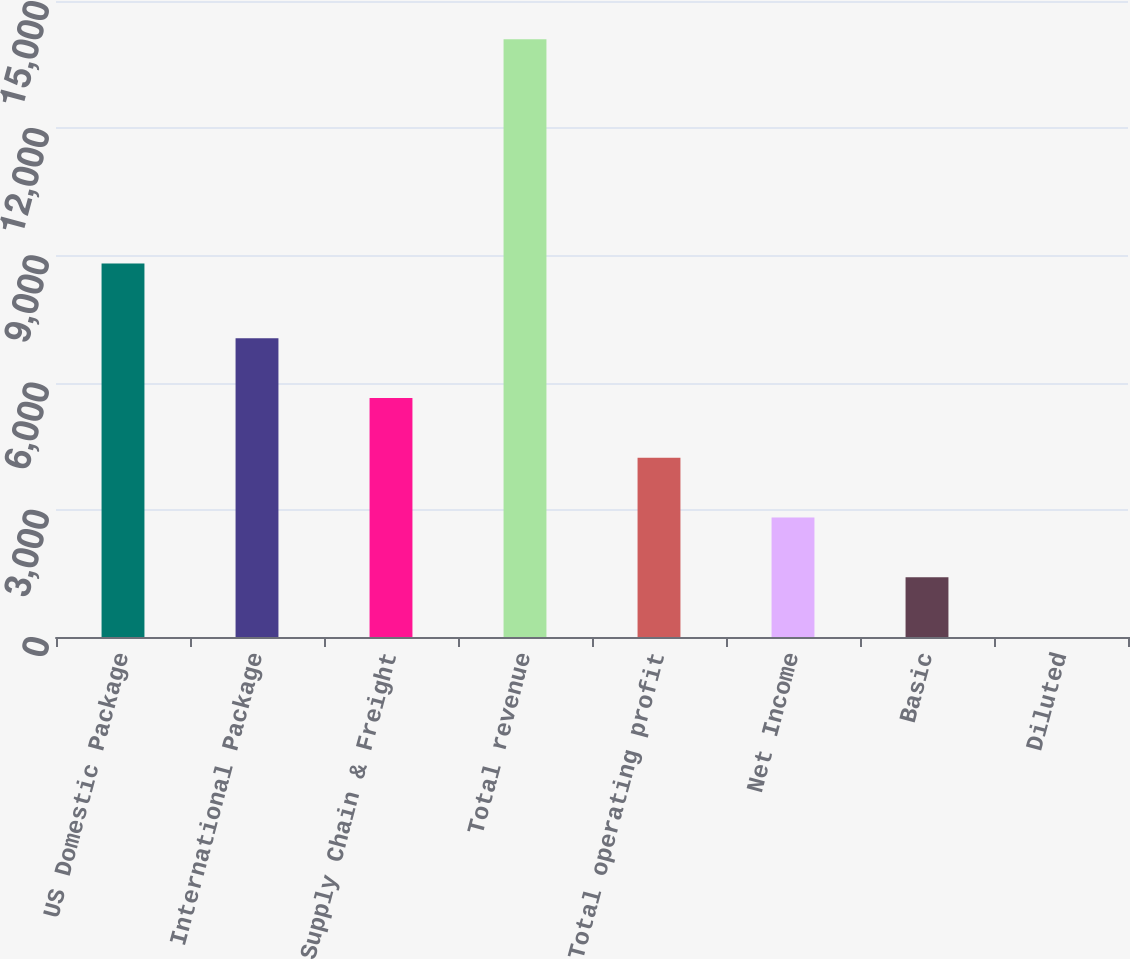Convert chart to OTSL. <chart><loc_0><loc_0><loc_500><loc_500><bar_chart><fcel>US Domestic Package<fcel>International Package<fcel>Supply Chain & Freight<fcel>Total revenue<fcel>Total operating profit<fcel>Net Income<fcel>Basic<fcel>Diluted<nl><fcel>8808<fcel>7048.16<fcel>5638.8<fcel>14095<fcel>4229.44<fcel>2820.07<fcel>1410.71<fcel>1.35<nl></chart> 